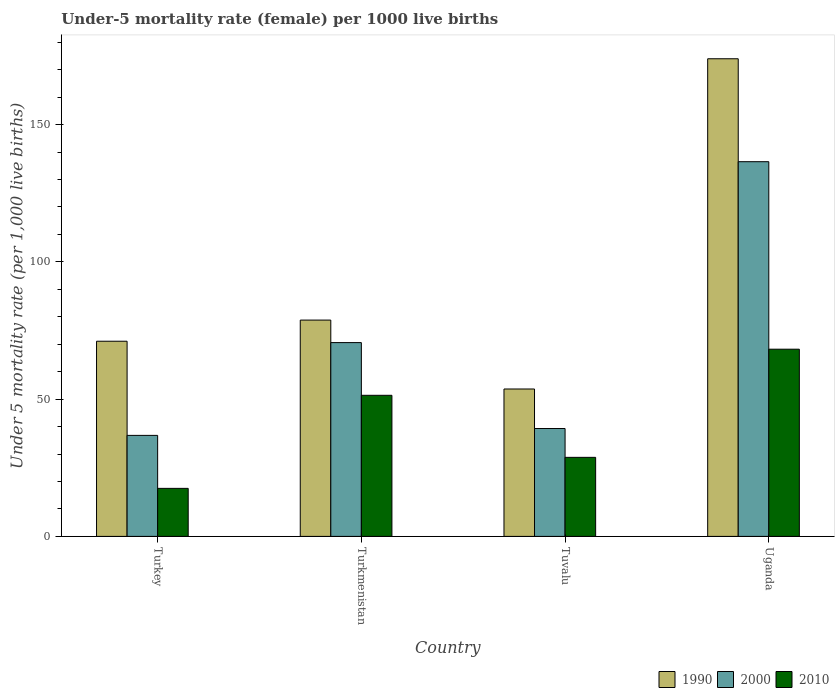How many groups of bars are there?
Provide a succinct answer. 4. What is the label of the 2nd group of bars from the left?
Offer a very short reply. Turkmenistan. In how many cases, is the number of bars for a given country not equal to the number of legend labels?
Keep it short and to the point. 0. What is the under-five mortality rate in 1990 in Uganda?
Keep it short and to the point. 174. Across all countries, what is the maximum under-five mortality rate in 2000?
Offer a terse response. 136.5. Across all countries, what is the minimum under-five mortality rate in 1990?
Offer a terse response. 53.7. In which country was the under-five mortality rate in 1990 maximum?
Offer a very short reply. Uganda. What is the total under-five mortality rate in 1990 in the graph?
Keep it short and to the point. 377.6. What is the difference between the under-five mortality rate in 2010 in Turkey and that in Turkmenistan?
Your answer should be very brief. -33.9. What is the difference between the under-five mortality rate in 2000 in Uganda and the under-five mortality rate in 1990 in Tuvalu?
Make the answer very short. 82.8. What is the average under-five mortality rate in 1990 per country?
Your answer should be very brief. 94.4. What is the difference between the under-five mortality rate of/in 2000 and under-five mortality rate of/in 2010 in Turkmenistan?
Your answer should be compact. 19.2. What is the ratio of the under-five mortality rate in 2010 in Tuvalu to that in Uganda?
Offer a terse response. 0.42. Is the under-five mortality rate in 2010 in Tuvalu less than that in Uganda?
Your response must be concise. Yes. Is the difference between the under-five mortality rate in 2000 in Turkey and Uganda greater than the difference between the under-five mortality rate in 2010 in Turkey and Uganda?
Provide a succinct answer. No. What is the difference between the highest and the second highest under-five mortality rate in 1990?
Your response must be concise. -95.2. What is the difference between the highest and the lowest under-five mortality rate in 1990?
Offer a terse response. 120.3. Is the sum of the under-five mortality rate in 2000 in Turkey and Uganda greater than the maximum under-five mortality rate in 2010 across all countries?
Your response must be concise. Yes. What does the 1st bar from the right in Uganda represents?
Your response must be concise. 2010. Is it the case that in every country, the sum of the under-five mortality rate in 2000 and under-five mortality rate in 1990 is greater than the under-five mortality rate in 2010?
Your answer should be very brief. Yes. How many bars are there?
Offer a terse response. 12. How many countries are there in the graph?
Offer a very short reply. 4. Does the graph contain any zero values?
Provide a short and direct response. No. Does the graph contain grids?
Give a very brief answer. No. What is the title of the graph?
Your answer should be compact. Under-5 mortality rate (female) per 1000 live births. What is the label or title of the X-axis?
Offer a terse response. Country. What is the label or title of the Y-axis?
Offer a very short reply. Under 5 mortality rate (per 1,0 live births). What is the Under 5 mortality rate (per 1,000 live births) in 1990 in Turkey?
Your response must be concise. 71.1. What is the Under 5 mortality rate (per 1,000 live births) of 2000 in Turkey?
Ensure brevity in your answer.  36.8. What is the Under 5 mortality rate (per 1,000 live births) of 2010 in Turkey?
Your response must be concise. 17.5. What is the Under 5 mortality rate (per 1,000 live births) of 1990 in Turkmenistan?
Your answer should be very brief. 78.8. What is the Under 5 mortality rate (per 1,000 live births) in 2000 in Turkmenistan?
Your response must be concise. 70.6. What is the Under 5 mortality rate (per 1,000 live births) in 2010 in Turkmenistan?
Offer a terse response. 51.4. What is the Under 5 mortality rate (per 1,000 live births) of 1990 in Tuvalu?
Offer a very short reply. 53.7. What is the Under 5 mortality rate (per 1,000 live births) of 2000 in Tuvalu?
Keep it short and to the point. 39.3. What is the Under 5 mortality rate (per 1,000 live births) in 2010 in Tuvalu?
Your response must be concise. 28.8. What is the Under 5 mortality rate (per 1,000 live births) in 1990 in Uganda?
Your answer should be very brief. 174. What is the Under 5 mortality rate (per 1,000 live births) in 2000 in Uganda?
Make the answer very short. 136.5. What is the Under 5 mortality rate (per 1,000 live births) in 2010 in Uganda?
Your response must be concise. 68.2. Across all countries, what is the maximum Under 5 mortality rate (per 1,000 live births) of 1990?
Your response must be concise. 174. Across all countries, what is the maximum Under 5 mortality rate (per 1,000 live births) in 2000?
Make the answer very short. 136.5. Across all countries, what is the maximum Under 5 mortality rate (per 1,000 live births) of 2010?
Your answer should be compact. 68.2. Across all countries, what is the minimum Under 5 mortality rate (per 1,000 live births) of 1990?
Provide a short and direct response. 53.7. Across all countries, what is the minimum Under 5 mortality rate (per 1,000 live births) of 2000?
Ensure brevity in your answer.  36.8. What is the total Under 5 mortality rate (per 1,000 live births) in 1990 in the graph?
Give a very brief answer. 377.6. What is the total Under 5 mortality rate (per 1,000 live births) of 2000 in the graph?
Keep it short and to the point. 283.2. What is the total Under 5 mortality rate (per 1,000 live births) of 2010 in the graph?
Your answer should be compact. 165.9. What is the difference between the Under 5 mortality rate (per 1,000 live births) in 2000 in Turkey and that in Turkmenistan?
Your answer should be very brief. -33.8. What is the difference between the Under 5 mortality rate (per 1,000 live births) of 2010 in Turkey and that in Turkmenistan?
Offer a very short reply. -33.9. What is the difference between the Under 5 mortality rate (per 1,000 live births) of 1990 in Turkey and that in Tuvalu?
Your response must be concise. 17.4. What is the difference between the Under 5 mortality rate (per 1,000 live births) of 2000 in Turkey and that in Tuvalu?
Make the answer very short. -2.5. What is the difference between the Under 5 mortality rate (per 1,000 live births) in 1990 in Turkey and that in Uganda?
Ensure brevity in your answer.  -102.9. What is the difference between the Under 5 mortality rate (per 1,000 live births) in 2000 in Turkey and that in Uganda?
Provide a succinct answer. -99.7. What is the difference between the Under 5 mortality rate (per 1,000 live births) of 2010 in Turkey and that in Uganda?
Your answer should be very brief. -50.7. What is the difference between the Under 5 mortality rate (per 1,000 live births) in 1990 in Turkmenistan and that in Tuvalu?
Provide a short and direct response. 25.1. What is the difference between the Under 5 mortality rate (per 1,000 live births) in 2000 in Turkmenistan and that in Tuvalu?
Your response must be concise. 31.3. What is the difference between the Under 5 mortality rate (per 1,000 live births) of 2010 in Turkmenistan and that in Tuvalu?
Your response must be concise. 22.6. What is the difference between the Under 5 mortality rate (per 1,000 live births) of 1990 in Turkmenistan and that in Uganda?
Provide a short and direct response. -95.2. What is the difference between the Under 5 mortality rate (per 1,000 live births) of 2000 in Turkmenistan and that in Uganda?
Your response must be concise. -65.9. What is the difference between the Under 5 mortality rate (per 1,000 live births) in 2010 in Turkmenistan and that in Uganda?
Provide a succinct answer. -16.8. What is the difference between the Under 5 mortality rate (per 1,000 live births) in 1990 in Tuvalu and that in Uganda?
Your answer should be compact. -120.3. What is the difference between the Under 5 mortality rate (per 1,000 live births) of 2000 in Tuvalu and that in Uganda?
Give a very brief answer. -97.2. What is the difference between the Under 5 mortality rate (per 1,000 live births) in 2010 in Tuvalu and that in Uganda?
Keep it short and to the point. -39.4. What is the difference between the Under 5 mortality rate (per 1,000 live births) in 2000 in Turkey and the Under 5 mortality rate (per 1,000 live births) in 2010 in Turkmenistan?
Ensure brevity in your answer.  -14.6. What is the difference between the Under 5 mortality rate (per 1,000 live births) of 1990 in Turkey and the Under 5 mortality rate (per 1,000 live births) of 2000 in Tuvalu?
Give a very brief answer. 31.8. What is the difference between the Under 5 mortality rate (per 1,000 live births) of 1990 in Turkey and the Under 5 mortality rate (per 1,000 live births) of 2010 in Tuvalu?
Offer a terse response. 42.3. What is the difference between the Under 5 mortality rate (per 1,000 live births) in 2000 in Turkey and the Under 5 mortality rate (per 1,000 live births) in 2010 in Tuvalu?
Make the answer very short. 8. What is the difference between the Under 5 mortality rate (per 1,000 live births) of 1990 in Turkey and the Under 5 mortality rate (per 1,000 live births) of 2000 in Uganda?
Provide a short and direct response. -65.4. What is the difference between the Under 5 mortality rate (per 1,000 live births) in 1990 in Turkey and the Under 5 mortality rate (per 1,000 live births) in 2010 in Uganda?
Offer a very short reply. 2.9. What is the difference between the Under 5 mortality rate (per 1,000 live births) of 2000 in Turkey and the Under 5 mortality rate (per 1,000 live births) of 2010 in Uganda?
Provide a succinct answer. -31.4. What is the difference between the Under 5 mortality rate (per 1,000 live births) in 1990 in Turkmenistan and the Under 5 mortality rate (per 1,000 live births) in 2000 in Tuvalu?
Make the answer very short. 39.5. What is the difference between the Under 5 mortality rate (per 1,000 live births) in 1990 in Turkmenistan and the Under 5 mortality rate (per 1,000 live births) in 2010 in Tuvalu?
Ensure brevity in your answer.  50. What is the difference between the Under 5 mortality rate (per 1,000 live births) of 2000 in Turkmenistan and the Under 5 mortality rate (per 1,000 live births) of 2010 in Tuvalu?
Offer a very short reply. 41.8. What is the difference between the Under 5 mortality rate (per 1,000 live births) of 1990 in Turkmenistan and the Under 5 mortality rate (per 1,000 live births) of 2000 in Uganda?
Offer a very short reply. -57.7. What is the difference between the Under 5 mortality rate (per 1,000 live births) of 1990 in Turkmenistan and the Under 5 mortality rate (per 1,000 live births) of 2010 in Uganda?
Give a very brief answer. 10.6. What is the difference between the Under 5 mortality rate (per 1,000 live births) in 2000 in Turkmenistan and the Under 5 mortality rate (per 1,000 live births) in 2010 in Uganda?
Offer a terse response. 2.4. What is the difference between the Under 5 mortality rate (per 1,000 live births) of 1990 in Tuvalu and the Under 5 mortality rate (per 1,000 live births) of 2000 in Uganda?
Make the answer very short. -82.8. What is the difference between the Under 5 mortality rate (per 1,000 live births) in 2000 in Tuvalu and the Under 5 mortality rate (per 1,000 live births) in 2010 in Uganda?
Your answer should be compact. -28.9. What is the average Under 5 mortality rate (per 1,000 live births) in 1990 per country?
Give a very brief answer. 94.4. What is the average Under 5 mortality rate (per 1,000 live births) of 2000 per country?
Your answer should be compact. 70.8. What is the average Under 5 mortality rate (per 1,000 live births) of 2010 per country?
Give a very brief answer. 41.48. What is the difference between the Under 5 mortality rate (per 1,000 live births) of 1990 and Under 5 mortality rate (per 1,000 live births) of 2000 in Turkey?
Make the answer very short. 34.3. What is the difference between the Under 5 mortality rate (per 1,000 live births) in 1990 and Under 5 mortality rate (per 1,000 live births) in 2010 in Turkey?
Your answer should be compact. 53.6. What is the difference between the Under 5 mortality rate (per 1,000 live births) of 2000 and Under 5 mortality rate (per 1,000 live births) of 2010 in Turkey?
Offer a very short reply. 19.3. What is the difference between the Under 5 mortality rate (per 1,000 live births) in 1990 and Under 5 mortality rate (per 1,000 live births) in 2000 in Turkmenistan?
Provide a short and direct response. 8.2. What is the difference between the Under 5 mortality rate (per 1,000 live births) of 1990 and Under 5 mortality rate (per 1,000 live births) of 2010 in Turkmenistan?
Offer a very short reply. 27.4. What is the difference between the Under 5 mortality rate (per 1,000 live births) of 1990 and Under 5 mortality rate (per 1,000 live births) of 2010 in Tuvalu?
Your response must be concise. 24.9. What is the difference between the Under 5 mortality rate (per 1,000 live births) in 1990 and Under 5 mortality rate (per 1,000 live births) in 2000 in Uganda?
Provide a short and direct response. 37.5. What is the difference between the Under 5 mortality rate (per 1,000 live births) of 1990 and Under 5 mortality rate (per 1,000 live births) of 2010 in Uganda?
Your answer should be compact. 105.8. What is the difference between the Under 5 mortality rate (per 1,000 live births) in 2000 and Under 5 mortality rate (per 1,000 live births) in 2010 in Uganda?
Offer a terse response. 68.3. What is the ratio of the Under 5 mortality rate (per 1,000 live births) in 1990 in Turkey to that in Turkmenistan?
Offer a very short reply. 0.9. What is the ratio of the Under 5 mortality rate (per 1,000 live births) of 2000 in Turkey to that in Turkmenistan?
Your response must be concise. 0.52. What is the ratio of the Under 5 mortality rate (per 1,000 live births) of 2010 in Turkey to that in Turkmenistan?
Your answer should be compact. 0.34. What is the ratio of the Under 5 mortality rate (per 1,000 live births) of 1990 in Turkey to that in Tuvalu?
Offer a terse response. 1.32. What is the ratio of the Under 5 mortality rate (per 1,000 live births) in 2000 in Turkey to that in Tuvalu?
Your answer should be very brief. 0.94. What is the ratio of the Under 5 mortality rate (per 1,000 live births) of 2010 in Turkey to that in Tuvalu?
Make the answer very short. 0.61. What is the ratio of the Under 5 mortality rate (per 1,000 live births) in 1990 in Turkey to that in Uganda?
Offer a very short reply. 0.41. What is the ratio of the Under 5 mortality rate (per 1,000 live births) of 2000 in Turkey to that in Uganda?
Your answer should be compact. 0.27. What is the ratio of the Under 5 mortality rate (per 1,000 live births) of 2010 in Turkey to that in Uganda?
Your answer should be compact. 0.26. What is the ratio of the Under 5 mortality rate (per 1,000 live births) in 1990 in Turkmenistan to that in Tuvalu?
Give a very brief answer. 1.47. What is the ratio of the Under 5 mortality rate (per 1,000 live births) of 2000 in Turkmenistan to that in Tuvalu?
Your answer should be compact. 1.8. What is the ratio of the Under 5 mortality rate (per 1,000 live births) in 2010 in Turkmenistan to that in Tuvalu?
Keep it short and to the point. 1.78. What is the ratio of the Under 5 mortality rate (per 1,000 live births) in 1990 in Turkmenistan to that in Uganda?
Give a very brief answer. 0.45. What is the ratio of the Under 5 mortality rate (per 1,000 live births) of 2000 in Turkmenistan to that in Uganda?
Keep it short and to the point. 0.52. What is the ratio of the Under 5 mortality rate (per 1,000 live births) in 2010 in Turkmenistan to that in Uganda?
Your answer should be very brief. 0.75. What is the ratio of the Under 5 mortality rate (per 1,000 live births) of 1990 in Tuvalu to that in Uganda?
Ensure brevity in your answer.  0.31. What is the ratio of the Under 5 mortality rate (per 1,000 live births) of 2000 in Tuvalu to that in Uganda?
Ensure brevity in your answer.  0.29. What is the ratio of the Under 5 mortality rate (per 1,000 live births) of 2010 in Tuvalu to that in Uganda?
Make the answer very short. 0.42. What is the difference between the highest and the second highest Under 5 mortality rate (per 1,000 live births) in 1990?
Your answer should be very brief. 95.2. What is the difference between the highest and the second highest Under 5 mortality rate (per 1,000 live births) in 2000?
Your answer should be very brief. 65.9. What is the difference between the highest and the lowest Under 5 mortality rate (per 1,000 live births) in 1990?
Your answer should be compact. 120.3. What is the difference between the highest and the lowest Under 5 mortality rate (per 1,000 live births) of 2000?
Offer a terse response. 99.7. What is the difference between the highest and the lowest Under 5 mortality rate (per 1,000 live births) of 2010?
Make the answer very short. 50.7. 